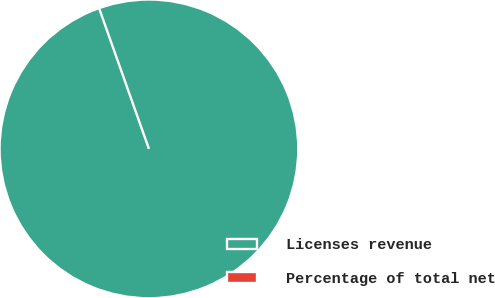<chart> <loc_0><loc_0><loc_500><loc_500><pie_chart><fcel>Licenses revenue<fcel>Percentage of total net<nl><fcel>100.0%<fcel>0.0%<nl></chart> 